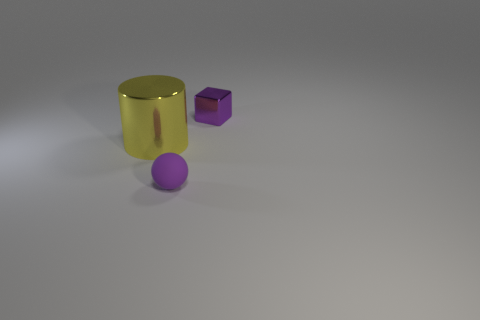Are there any other things that are made of the same material as the ball?
Provide a succinct answer. No. Are there any other things that have the same size as the purple shiny thing?
Offer a terse response. Yes. What size is the metallic cube that is the same color as the tiny rubber object?
Your response must be concise. Small. There is a purple object in front of the small purple cube; what is it made of?
Your answer should be compact. Rubber. Are there the same number of purple matte things to the right of the metal cylinder and small metallic objects on the left side of the small matte thing?
Your answer should be very brief. No. Do the thing that is in front of the yellow object and the object right of the purple rubber ball have the same size?
Keep it short and to the point. Yes. What number of large shiny things have the same color as the shiny cylinder?
Give a very brief answer. 0. There is another thing that is the same color as the matte thing; what is it made of?
Keep it short and to the point. Metal. Are there more large shiny things that are on the left side of the purple ball than large gray shiny cylinders?
Ensure brevity in your answer.  Yes. What number of small gray balls are the same material as the large object?
Provide a succinct answer. 0. 